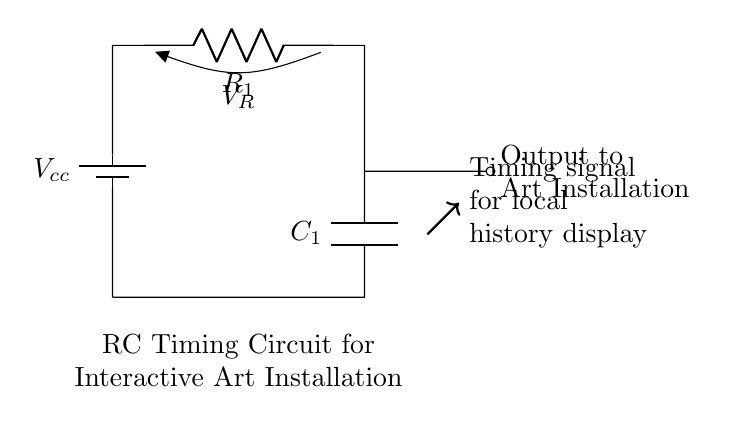What are the components in this circuit? The circuit has a battery, a resistor, and a capacitor. The battery provides voltage, the resistor limits current, and the capacitor stores charge.
Answer: battery, resistor, capacitor What does the output connect to in this circuit? The output is connected to the interactive art installation, which utilizes the timing signal generated by the circuit. This shows that the installation is designed to respond to the timing behavior of the circuit.
Answer: Art Installation What is the purpose of the resistor in this timing circuit? The resistor slows down the charging of the capacitor, which directly affects how quickly the timing circuit responds. This slows the rate at which the capacitor charges and discharges, defining the timing of the signal output.
Answer: Slows charging What is the role of the capacitor in this circuit? The capacitor stores electrical energy and releases it at a controlled rate. In this timing circuit, it creates a delay when charging or discharging, which determines the timing of the output signal to the art installation.
Answer: Stores energy How does the resistor affect the timing in this circuit? The resistance determines the time constant of the circuit, calculated as the product of resistance and capacitance (tau = R x C). A higher resistance results in a longer time delay for the charging and discharging of the capacitor, influencing the timing of the output signal.
Answer: Affects time constant What is the purpose of the timing signal produced? The timing signal controls when local history displays are activated in the interactive art installation. It ensures that presentations occur at intervals determined by the RC time constant, creating a rhythm for the exhibit.
Answer: Control display timing 